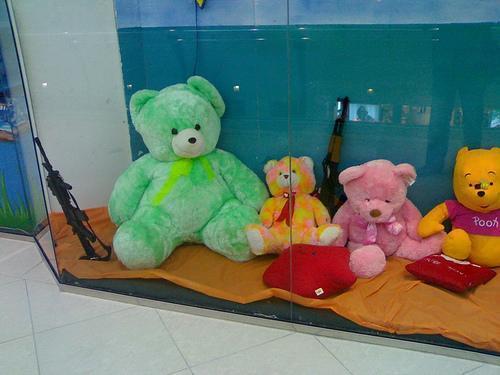How many pillows are there?
Give a very brief answer. 2. How many polar bears are there?
Give a very brief answer. 0. How many bears are there?
Give a very brief answer. 4. How many teddy bears are in the picture?
Give a very brief answer. 4. 